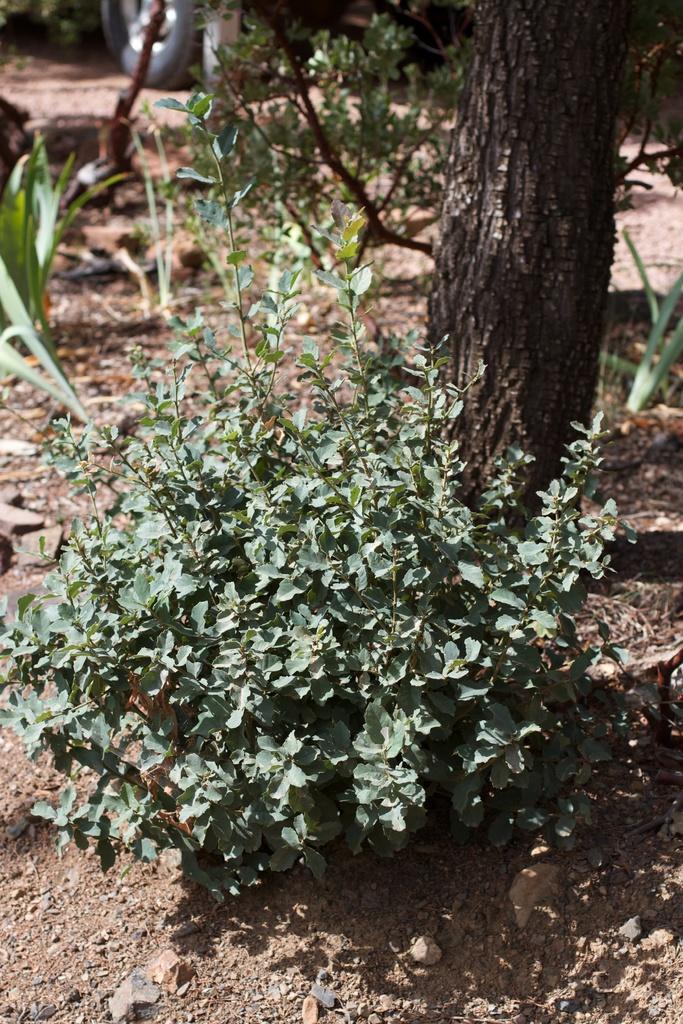In one or two sentences, can you explain what this image depicts? In front of the picture, we see a plant. Behind that, we see the stem of the tree and the plants. At the bottom, we see the soil. In the background, we see a vehicle. This picture is blurred in the background. 